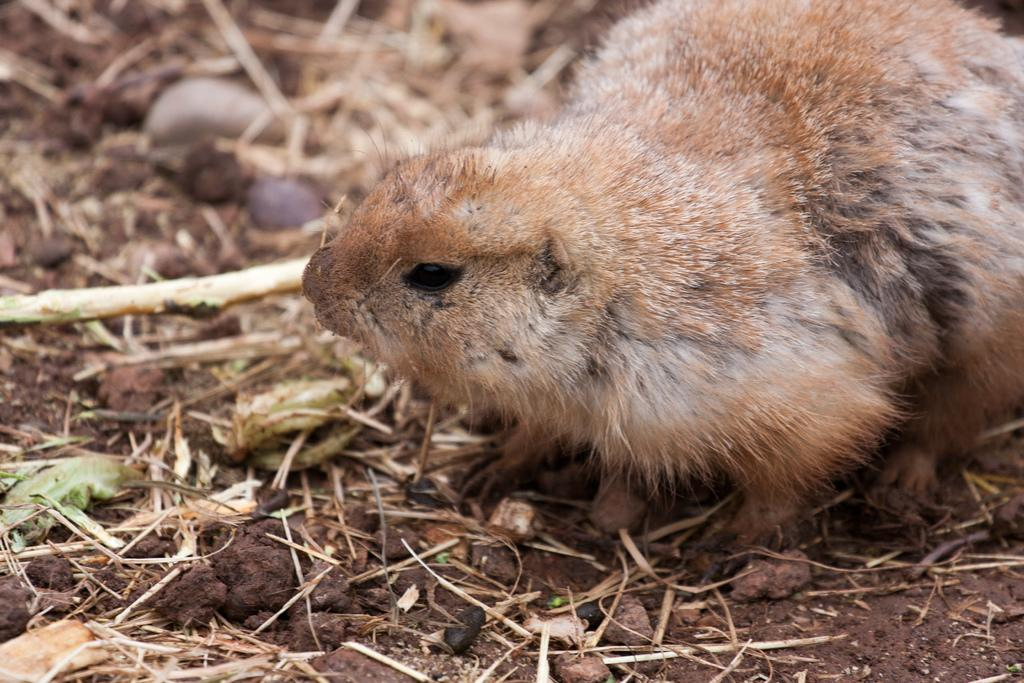What type of creature can be seen in the image? There is an animal in the image. Where is the animal located in the image? The animal is on the ground. What type of noise is the committee making in the image? There is no committee or noise present in the image; it features an animal on the ground. What type of kitty can be seen playing with the animal in the image? There is no kitty present in the image, and the animal is not shown playing with any other creature. 